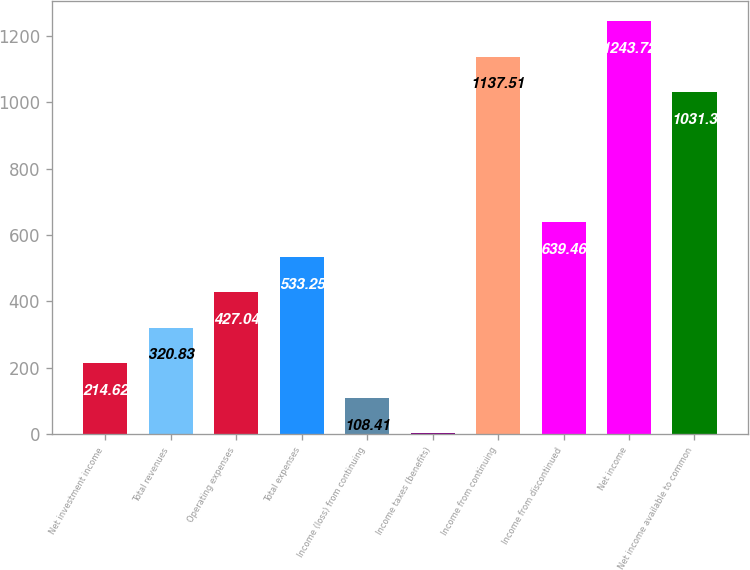<chart> <loc_0><loc_0><loc_500><loc_500><bar_chart><fcel>Net investment income<fcel>Total revenues<fcel>Operating expenses<fcel>Total expenses<fcel>Income (loss) from continuing<fcel>Income taxes (benefits)<fcel>Income from continuing<fcel>Income from discontinued<fcel>Net income<fcel>Net income available to common<nl><fcel>214.62<fcel>320.83<fcel>427.04<fcel>533.25<fcel>108.41<fcel>2.2<fcel>1137.51<fcel>639.46<fcel>1243.72<fcel>1031.3<nl></chart> 